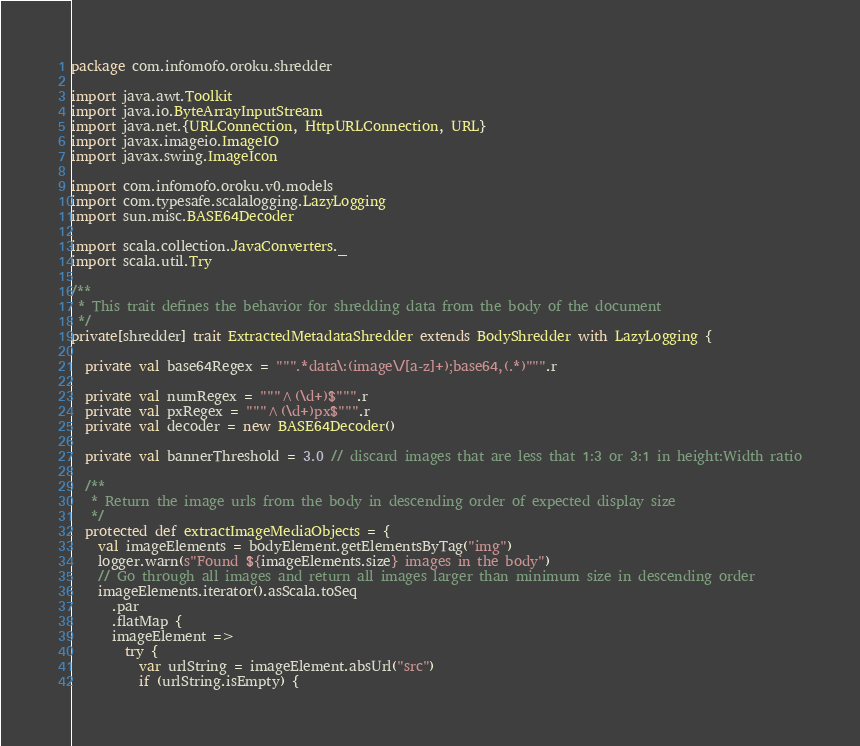Convert code to text. <code><loc_0><loc_0><loc_500><loc_500><_Scala_>package com.infomofo.oroku.shredder

import java.awt.Toolkit
import java.io.ByteArrayInputStream
import java.net.{URLConnection, HttpURLConnection, URL}
import javax.imageio.ImageIO
import javax.swing.ImageIcon

import com.infomofo.oroku.v0.models
import com.typesafe.scalalogging.LazyLogging
import sun.misc.BASE64Decoder

import scala.collection.JavaConverters._
import scala.util.Try

/**
 * This trait defines the behavior for shredding data from the body of the document
 */
private[shredder] trait ExtractedMetadataShredder extends BodyShredder with LazyLogging {

  private val base64Regex = """.*data\:(image\/[a-z]+);base64,(.*)""".r

  private val numRegex = """^(\d+)$""".r
  private val pxRegex = """^(\d+)px$""".r
  private val decoder = new BASE64Decoder()

  private val bannerThreshold = 3.0 // discard images that are less that 1:3 or 3:1 in height:Width ratio

  /**
   * Return the image urls from the body in descending order of expected display size
   */
  protected def extractImageMediaObjects = {
    val imageElements = bodyElement.getElementsByTag("img")
    logger.warn(s"Found ${imageElements.size} images in the body")
    // Go through all images and return all images larger than minimum size in descending order
    imageElements.iterator().asScala.toSeq
      .par
      .flatMap {
      imageElement =>
        try {
          var urlString = imageElement.absUrl("src")
          if (urlString.isEmpty) {</code> 